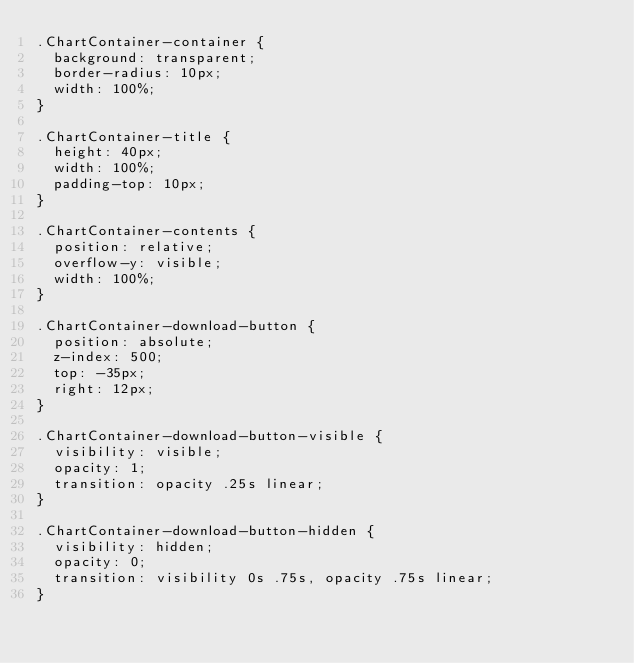<code> <loc_0><loc_0><loc_500><loc_500><_CSS_>.ChartContainer-container {
  background: transparent;
  border-radius: 10px;
  width: 100%;
}

.ChartContainer-title {
  height: 40px;
  width: 100%;
  padding-top: 10px;
}

.ChartContainer-contents {
  position: relative;
  overflow-y: visible;
  width: 100%;
}

.ChartContainer-download-button {
  position: absolute;
  z-index: 500;
  top: -35px;
  right: 12px;
}

.ChartContainer-download-button-visible {
  visibility: visible;
  opacity: 1;
  transition: opacity .25s linear;
}

.ChartContainer-download-button-hidden {
  visibility: hidden;
  opacity: 0;
  transition: visibility 0s .75s, opacity .75s linear;
}

</code> 